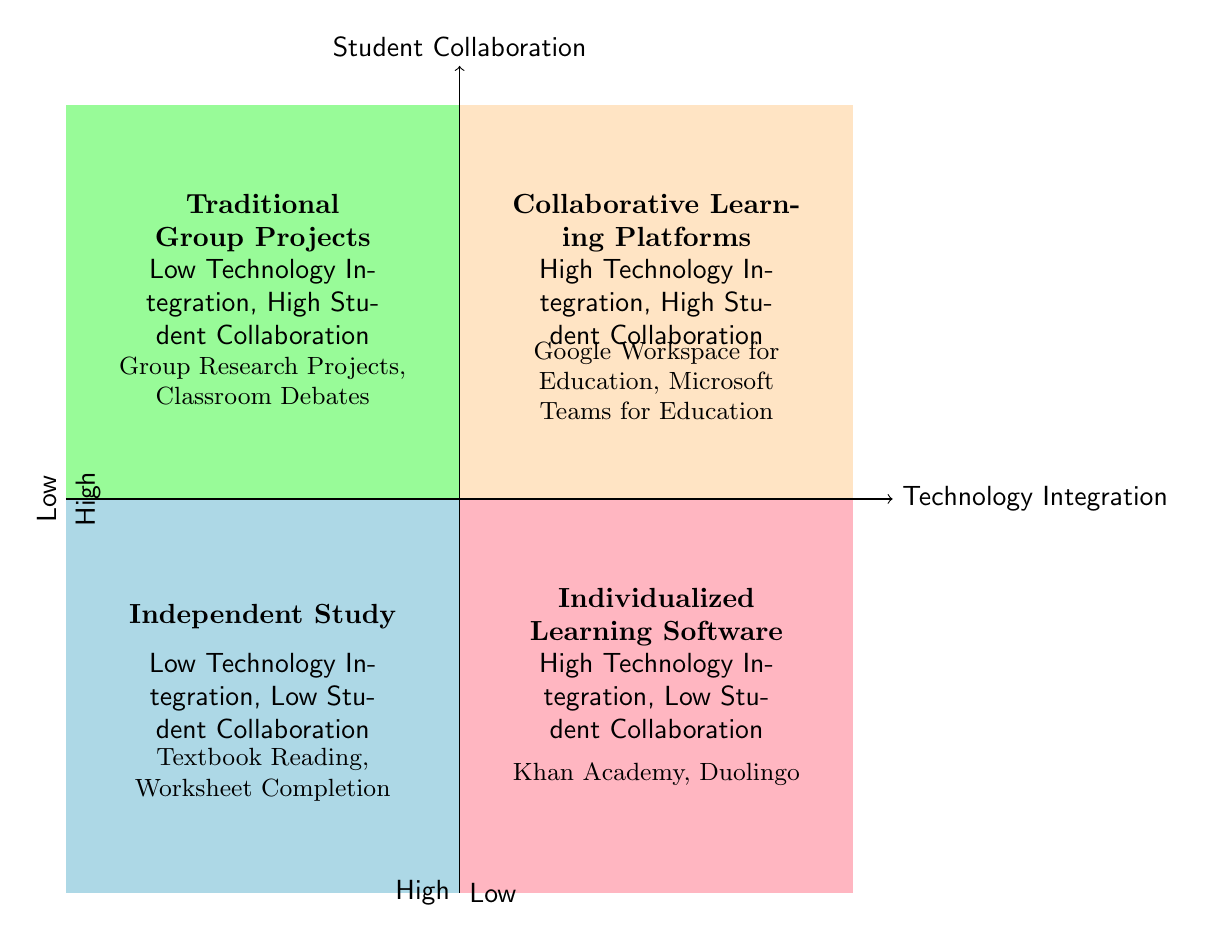What is located in the High Technology Integration, High Student Collaboration quadrant? The diagram shows "Collaborative Learning Platforms" in this quadrant, which are tools enabling real-time collaboration among students.
Answer: Collaborative Learning Platforms How many examples are provided for Individualized Learning Software? The quadrant lists two examples: "Khan Academy" and "Duolingo," indicating that there are two tools for this category.
Answer: 2 Which quadrant contains Traditional Group Projects? The diagram indicates that Traditional Group Projects are placed in the Low Technology Integration, High Student Collaboration quadrant, which is in the upper left.
Answer: Low Technology Integration, High Student Collaboration What types of activities are categorized under Low Technology Integration, Low Student Collaboration? The description for this quadrant mentions "Independent Study," which includes textbook reading and worksheet completion.
Answer: Independent Study In which quadrant are Google Workspace for Education and Microsoft Teams for Education found? These two platforms are examples listed under the High Technology Integration, High Student Collaboration quadrant, indicating they promote both technology use and collaboration.
Answer: High Technology Integration, High Student Collaboration What does Independent Study typically involve? The diagram states that Independent Study involves individual tasks such as textbook reading and worksheet completion, indicating minimal interaction and low technology use.
Answer: Textbook Reading, Worksheet Completion Which quadrant has a focus on collaborative learning without high technology integration? The Low Technology Integration, High Student Collaboration quadrant focuses on traditional group projects, indicating cooperation without reliance on significant technology.
Answer: Low Technology Integration, High Student Collaboration How many quadrants in the diagram describe categories with high technology integration? There are two quadrants that describe high technology integration: High Technology Integration, High Student Collaboration and High Technology Integration, Low Student Collaboration.
Answer: 2 What category supports personalized learning experiences but lacks collaboration? Individualized Learning Software is the category that supports personalized learning experiences while lacking collaborative elements.
Answer: Individualized Learning Software 